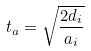<formula> <loc_0><loc_0><loc_500><loc_500>t _ { a } = \sqrt { \frac { 2 d _ { i } } { a _ { i } } }</formula> 